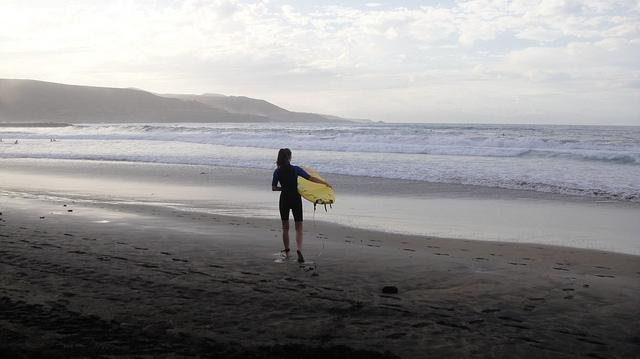Is the sky cloudy or clear?
Be succinct. Cloudy. What color is the surfboard?
Concise answer only. Yellow. What is the person walking on?
Write a very short answer. Sand. What color shorts are they wearing?
Short answer required. Black. 